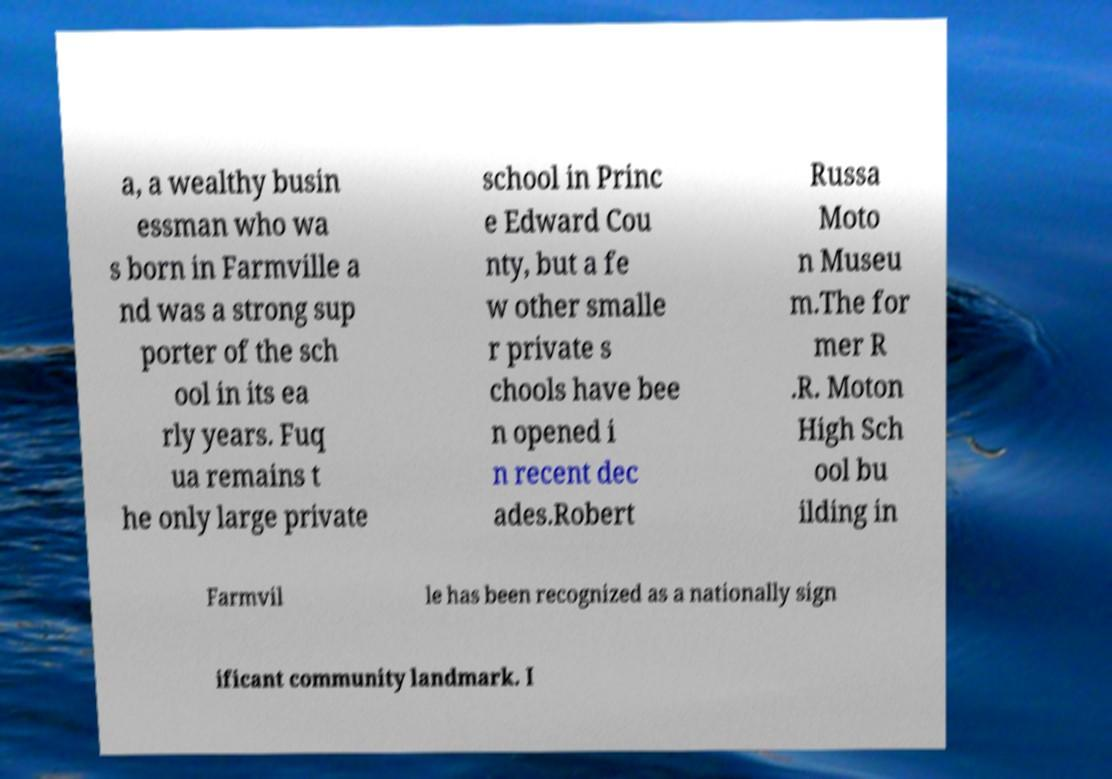Please read and relay the text visible in this image. What does it say? a, a wealthy busin essman who wa s born in Farmville a nd was a strong sup porter of the sch ool in its ea rly years. Fuq ua remains t he only large private school in Princ e Edward Cou nty, but a fe w other smalle r private s chools have bee n opened i n recent dec ades.Robert Russa Moto n Museu m.The for mer R .R. Moton High Sch ool bu ilding in Farmvil le has been recognized as a nationally sign ificant community landmark. I 